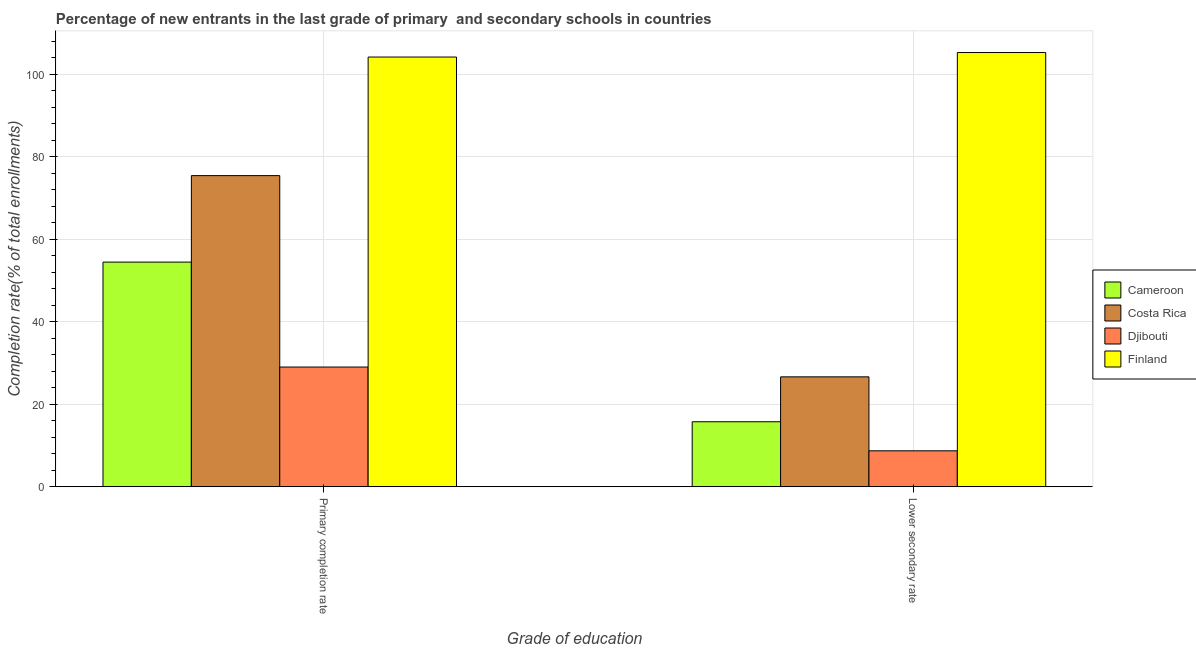How many different coloured bars are there?
Give a very brief answer. 4. How many groups of bars are there?
Your answer should be compact. 2. How many bars are there on the 2nd tick from the right?
Your answer should be very brief. 4. What is the label of the 2nd group of bars from the left?
Make the answer very short. Lower secondary rate. What is the completion rate in secondary schools in Djibouti?
Offer a terse response. 8.71. Across all countries, what is the maximum completion rate in primary schools?
Offer a terse response. 104.13. Across all countries, what is the minimum completion rate in secondary schools?
Make the answer very short. 8.71. In which country was the completion rate in primary schools minimum?
Ensure brevity in your answer.  Djibouti. What is the total completion rate in primary schools in the graph?
Your answer should be compact. 262.97. What is the difference between the completion rate in primary schools in Djibouti and that in Costa Rica?
Keep it short and to the point. -46.39. What is the difference between the completion rate in primary schools in Djibouti and the completion rate in secondary schools in Finland?
Your answer should be compact. -76.22. What is the average completion rate in secondary schools per country?
Keep it short and to the point. 39.08. What is the difference between the completion rate in secondary schools and completion rate in primary schools in Costa Rica?
Offer a very short reply. -48.77. What is the ratio of the completion rate in primary schools in Cameroon to that in Costa Rica?
Your answer should be very brief. 0.72. Is the completion rate in secondary schools in Costa Rica less than that in Cameroon?
Offer a terse response. No. What does the 1st bar from the left in Lower secondary rate represents?
Offer a terse response. Cameroon. How many bars are there?
Your answer should be compact. 8. Where does the legend appear in the graph?
Give a very brief answer. Center right. How many legend labels are there?
Provide a succinct answer. 4. How are the legend labels stacked?
Give a very brief answer. Vertical. What is the title of the graph?
Provide a short and direct response. Percentage of new entrants in the last grade of primary  and secondary schools in countries. Does "Swaziland" appear as one of the legend labels in the graph?
Provide a succinct answer. No. What is the label or title of the X-axis?
Ensure brevity in your answer.  Grade of education. What is the label or title of the Y-axis?
Provide a succinct answer. Completion rate(% of total enrollments). What is the Completion rate(% of total enrollments) in Cameroon in Primary completion rate?
Offer a terse response. 54.44. What is the Completion rate(% of total enrollments) in Costa Rica in Primary completion rate?
Provide a short and direct response. 75.4. What is the Completion rate(% of total enrollments) of Djibouti in Primary completion rate?
Provide a succinct answer. 29. What is the Completion rate(% of total enrollments) in Finland in Primary completion rate?
Your answer should be very brief. 104.13. What is the Completion rate(% of total enrollments) of Cameroon in Lower secondary rate?
Your response must be concise. 15.74. What is the Completion rate(% of total enrollments) of Costa Rica in Lower secondary rate?
Offer a very short reply. 26.63. What is the Completion rate(% of total enrollments) in Djibouti in Lower secondary rate?
Give a very brief answer. 8.71. What is the Completion rate(% of total enrollments) in Finland in Lower secondary rate?
Give a very brief answer. 105.22. Across all Grade of education, what is the maximum Completion rate(% of total enrollments) in Cameroon?
Provide a short and direct response. 54.44. Across all Grade of education, what is the maximum Completion rate(% of total enrollments) in Costa Rica?
Provide a succinct answer. 75.4. Across all Grade of education, what is the maximum Completion rate(% of total enrollments) in Djibouti?
Make the answer very short. 29. Across all Grade of education, what is the maximum Completion rate(% of total enrollments) of Finland?
Ensure brevity in your answer.  105.22. Across all Grade of education, what is the minimum Completion rate(% of total enrollments) of Cameroon?
Provide a succinct answer. 15.74. Across all Grade of education, what is the minimum Completion rate(% of total enrollments) in Costa Rica?
Your answer should be compact. 26.63. Across all Grade of education, what is the minimum Completion rate(% of total enrollments) in Djibouti?
Give a very brief answer. 8.71. Across all Grade of education, what is the minimum Completion rate(% of total enrollments) of Finland?
Provide a short and direct response. 104.13. What is the total Completion rate(% of total enrollments) of Cameroon in the graph?
Provide a succinct answer. 70.18. What is the total Completion rate(% of total enrollments) in Costa Rica in the graph?
Provide a succinct answer. 102.02. What is the total Completion rate(% of total enrollments) in Djibouti in the graph?
Give a very brief answer. 37.71. What is the total Completion rate(% of total enrollments) in Finland in the graph?
Offer a terse response. 209.35. What is the difference between the Completion rate(% of total enrollments) of Cameroon in Primary completion rate and that in Lower secondary rate?
Your response must be concise. 38.69. What is the difference between the Completion rate(% of total enrollments) in Costa Rica in Primary completion rate and that in Lower secondary rate?
Offer a terse response. 48.77. What is the difference between the Completion rate(% of total enrollments) in Djibouti in Primary completion rate and that in Lower secondary rate?
Keep it short and to the point. 20.3. What is the difference between the Completion rate(% of total enrollments) in Finland in Primary completion rate and that in Lower secondary rate?
Ensure brevity in your answer.  -1.09. What is the difference between the Completion rate(% of total enrollments) of Cameroon in Primary completion rate and the Completion rate(% of total enrollments) of Costa Rica in Lower secondary rate?
Your answer should be compact. 27.81. What is the difference between the Completion rate(% of total enrollments) of Cameroon in Primary completion rate and the Completion rate(% of total enrollments) of Djibouti in Lower secondary rate?
Your answer should be compact. 45.73. What is the difference between the Completion rate(% of total enrollments) in Cameroon in Primary completion rate and the Completion rate(% of total enrollments) in Finland in Lower secondary rate?
Provide a succinct answer. -50.79. What is the difference between the Completion rate(% of total enrollments) in Costa Rica in Primary completion rate and the Completion rate(% of total enrollments) in Djibouti in Lower secondary rate?
Give a very brief answer. 66.69. What is the difference between the Completion rate(% of total enrollments) in Costa Rica in Primary completion rate and the Completion rate(% of total enrollments) in Finland in Lower secondary rate?
Keep it short and to the point. -29.83. What is the difference between the Completion rate(% of total enrollments) of Djibouti in Primary completion rate and the Completion rate(% of total enrollments) of Finland in Lower secondary rate?
Offer a very short reply. -76.22. What is the average Completion rate(% of total enrollments) of Cameroon per Grade of education?
Offer a very short reply. 35.09. What is the average Completion rate(% of total enrollments) in Costa Rica per Grade of education?
Your answer should be compact. 51.01. What is the average Completion rate(% of total enrollments) of Djibouti per Grade of education?
Give a very brief answer. 18.86. What is the average Completion rate(% of total enrollments) in Finland per Grade of education?
Your answer should be compact. 104.68. What is the difference between the Completion rate(% of total enrollments) in Cameroon and Completion rate(% of total enrollments) in Costa Rica in Primary completion rate?
Make the answer very short. -20.96. What is the difference between the Completion rate(% of total enrollments) in Cameroon and Completion rate(% of total enrollments) in Djibouti in Primary completion rate?
Your response must be concise. 25.43. What is the difference between the Completion rate(% of total enrollments) of Cameroon and Completion rate(% of total enrollments) of Finland in Primary completion rate?
Offer a terse response. -49.69. What is the difference between the Completion rate(% of total enrollments) of Costa Rica and Completion rate(% of total enrollments) of Djibouti in Primary completion rate?
Your response must be concise. 46.39. What is the difference between the Completion rate(% of total enrollments) of Costa Rica and Completion rate(% of total enrollments) of Finland in Primary completion rate?
Keep it short and to the point. -28.73. What is the difference between the Completion rate(% of total enrollments) of Djibouti and Completion rate(% of total enrollments) of Finland in Primary completion rate?
Your answer should be compact. -75.12. What is the difference between the Completion rate(% of total enrollments) in Cameroon and Completion rate(% of total enrollments) in Costa Rica in Lower secondary rate?
Your response must be concise. -10.88. What is the difference between the Completion rate(% of total enrollments) in Cameroon and Completion rate(% of total enrollments) in Djibouti in Lower secondary rate?
Make the answer very short. 7.04. What is the difference between the Completion rate(% of total enrollments) of Cameroon and Completion rate(% of total enrollments) of Finland in Lower secondary rate?
Offer a very short reply. -89.48. What is the difference between the Completion rate(% of total enrollments) in Costa Rica and Completion rate(% of total enrollments) in Djibouti in Lower secondary rate?
Your answer should be very brief. 17.92. What is the difference between the Completion rate(% of total enrollments) in Costa Rica and Completion rate(% of total enrollments) in Finland in Lower secondary rate?
Your answer should be compact. -78.59. What is the difference between the Completion rate(% of total enrollments) in Djibouti and Completion rate(% of total enrollments) in Finland in Lower secondary rate?
Your response must be concise. -96.52. What is the ratio of the Completion rate(% of total enrollments) of Cameroon in Primary completion rate to that in Lower secondary rate?
Provide a short and direct response. 3.46. What is the ratio of the Completion rate(% of total enrollments) of Costa Rica in Primary completion rate to that in Lower secondary rate?
Make the answer very short. 2.83. What is the ratio of the Completion rate(% of total enrollments) in Djibouti in Primary completion rate to that in Lower secondary rate?
Provide a succinct answer. 3.33. What is the difference between the highest and the second highest Completion rate(% of total enrollments) of Cameroon?
Your answer should be very brief. 38.69. What is the difference between the highest and the second highest Completion rate(% of total enrollments) of Costa Rica?
Provide a succinct answer. 48.77. What is the difference between the highest and the second highest Completion rate(% of total enrollments) of Djibouti?
Make the answer very short. 20.3. What is the difference between the highest and the second highest Completion rate(% of total enrollments) of Finland?
Your answer should be very brief. 1.09. What is the difference between the highest and the lowest Completion rate(% of total enrollments) in Cameroon?
Give a very brief answer. 38.69. What is the difference between the highest and the lowest Completion rate(% of total enrollments) in Costa Rica?
Your answer should be compact. 48.77. What is the difference between the highest and the lowest Completion rate(% of total enrollments) in Djibouti?
Your answer should be compact. 20.3. What is the difference between the highest and the lowest Completion rate(% of total enrollments) in Finland?
Offer a terse response. 1.09. 